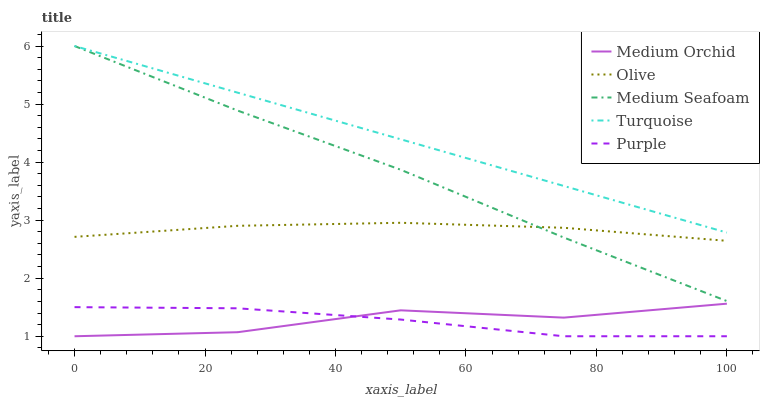Does Purple have the minimum area under the curve?
Answer yes or no. Yes. Does Turquoise have the maximum area under the curve?
Answer yes or no. Yes. Does Turquoise have the minimum area under the curve?
Answer yes or no. No. Does Purple have the maximum area under the curve?
Answer yes or no. No. Is Turquoise the smoothest?
Answer yes or no. Yes. Is Medium Orchid the roughest?
Answer yes or no. Yes. Is Purple the smoothest?
Answer yes or no. No. Is Purple the roughest?
Answer yes or no. No. Does Purple have the lowest value?
Answer yes or no. Yes. Does Turquoise have the lowest value?
Answer yes or no. No. Does Medium Seafoam have the highest value?
Answer yes or no. Yes. Does Purple have the highest value?
Answer yes or no. No. Is Purple less than Turquoise?
Answer yes or no. Yes. Is Turquoise greater than Medium Orchid?
Answer yes or no. Yes. Does Medium Seafoam intersect Olive?
Answer yes or no. Yes. Is Medium Seafoam less than Olive?
Answer yes or no. No. Is Medium Seafoam greater than Olive?
Answer yes or no. No. Does Purple intersect Turquoise?
Answer yes or no. No. 